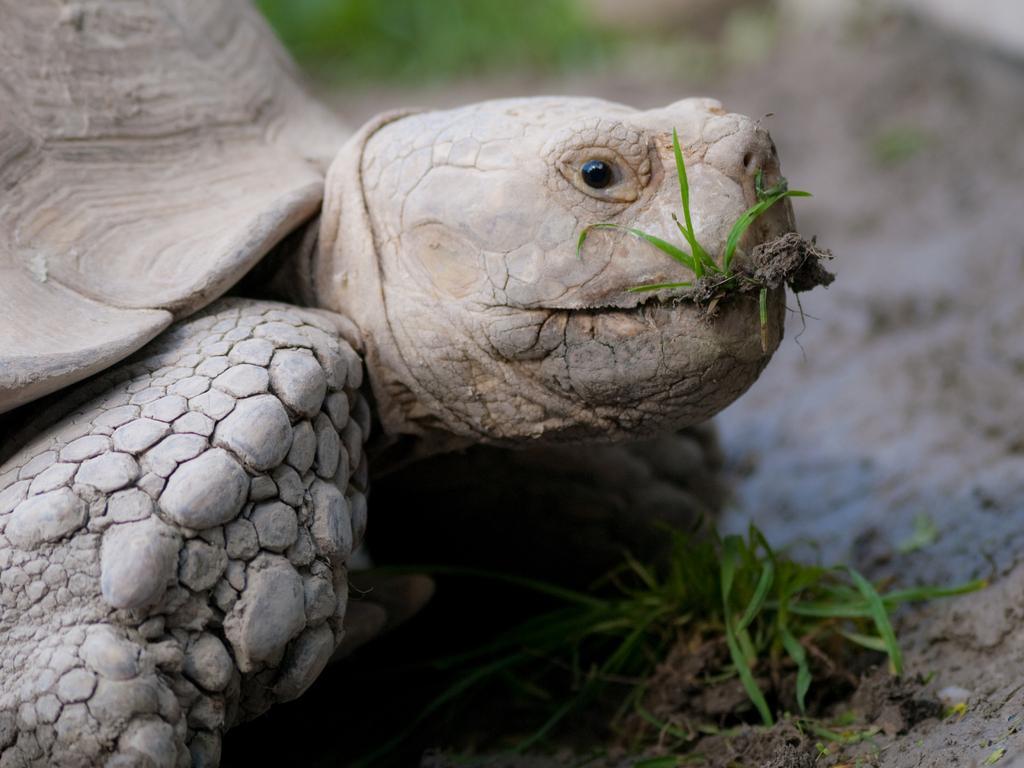Describe this image in one or two sentences. In this image we can see tortoise. Also there is grass. In the background it is blur. 